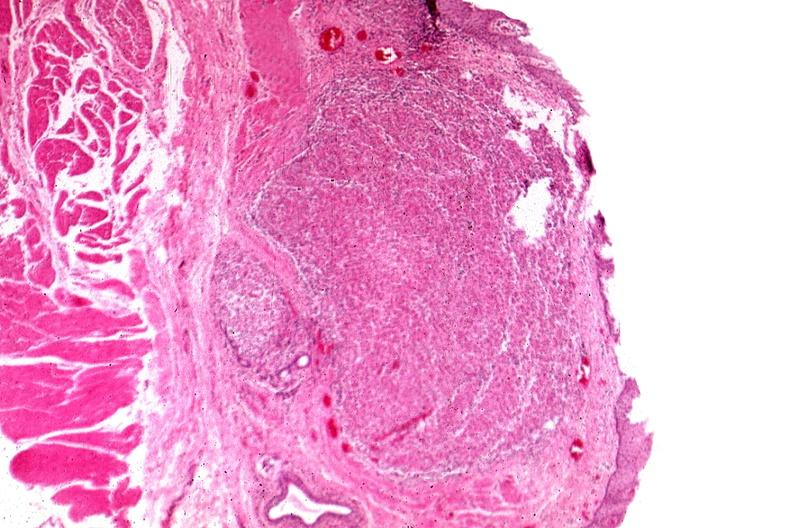what is present?
Answer the question using a single word or phrase. Gastrointestinal 